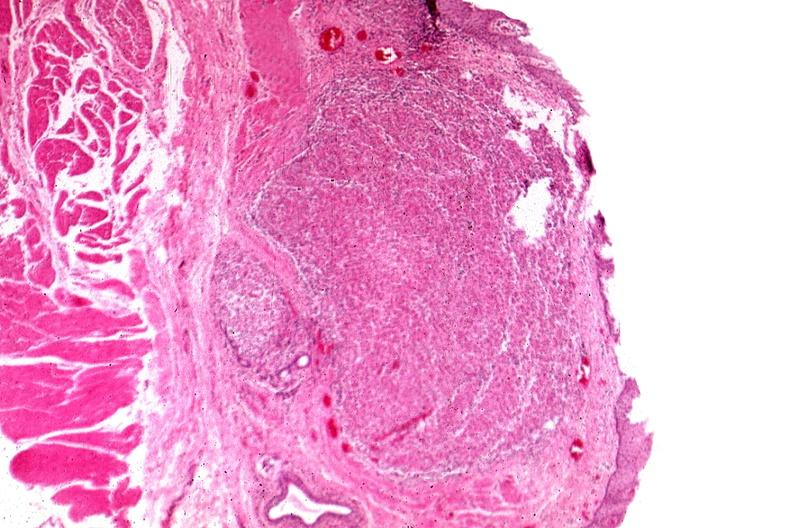what is present?
Answer the question using a single word or phrase. Gastrointestinal 